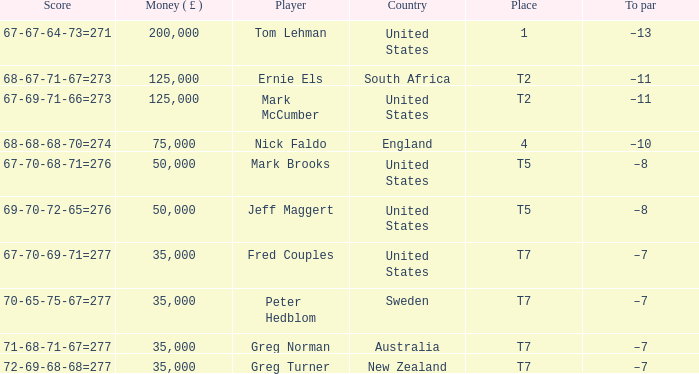When the player is greg turner, what is their to par score? –7. 